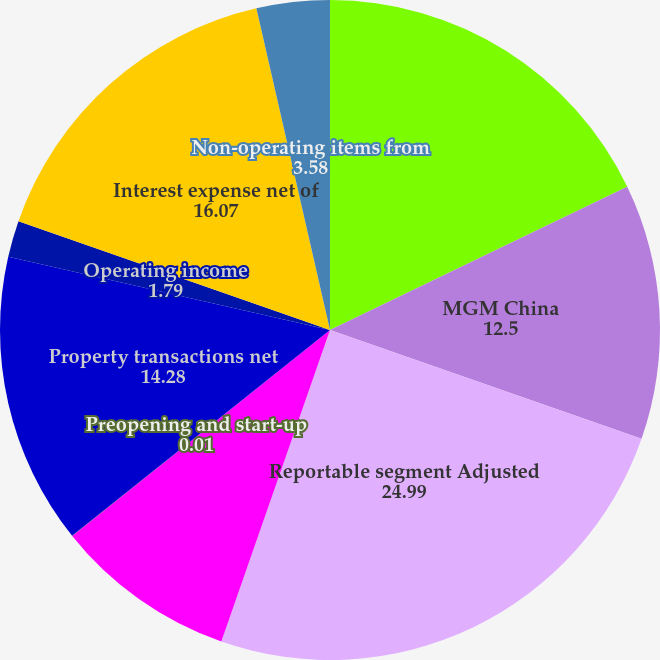Convert chart to OTSL. <chart><loc_0><loc_0><loc_500><loc_500><pie_chart><fcel>Wholly owned domestic resorts<fcel>MGM China<fcel>Reportable segment Adjusted<fcel>Corporate and other<fcel>Preopening and start-up<fcel>Property transactions net<fcel>Operating income<fcel>Interest expense net of<fcel>Non-operating items from<nl><fcel>17.85%<fcel>12.5%<fcel>24.99%<fcel>8.93%<fcel>0.01%<fcel>14.28%<fcel>1.79%<fcel>16.07%<fcel>3.58%<nl></chart> 